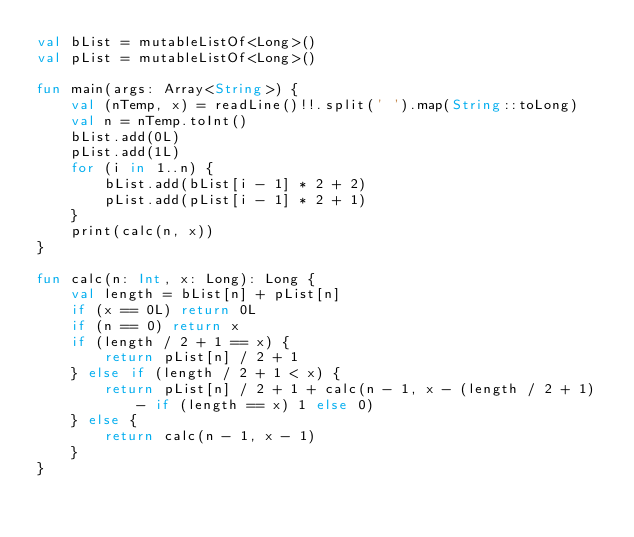<code> <loc_0><loc_0><loc_500><loc_500><_Kotlin_>val bList = mutableListOf<Long>()
val pList = mutableListOf<Long>()

fun main(args: Array<String>) {
    val (nTemp, x) = readLine()!!.split(' ').map(String::toLong)
    val n = nTemp.toInt()
    bList.add(0L)
    pList.add(1L)
    for (i in 1..n) {
        bList.add(bList[i - 1] * 2 + 2)
        pList.add(pList[i - 1] * 2 + 1)
    }
    print(calc(n, x))
}

fun calc(n: Int, x: Long): Long {
    val length = bList[n] + pList[n]
    if (x == 0L) return 0L
    if (n == 0) return x
    if (length / 2 + 1 == x) {
        return pList[n] / 2 + 1
    } else if (length / 2 + 1 < x) {
        return pList[n] / 2 + 1 + calc(n - 1, x - (length / 2 + 1) - if (length == x) 1 else 0)
    } else {
        return calc(n - 1, x - 1)
    }
}
</code> 